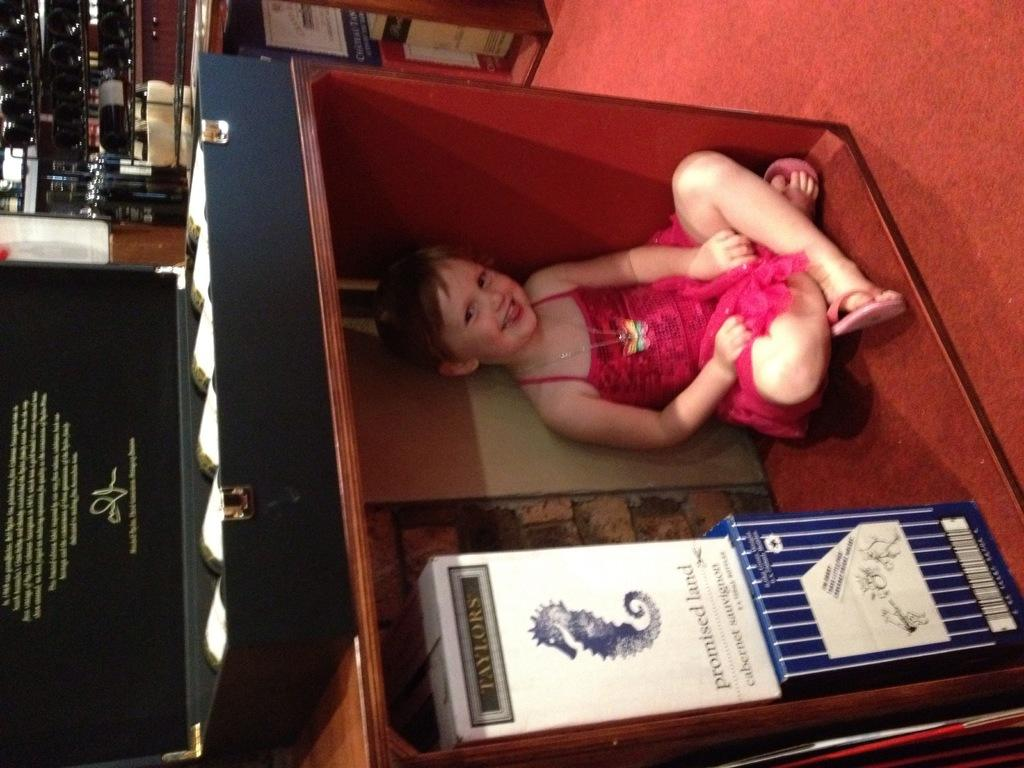What is the main subject of the picture? The main subject of the picture is a kid. What is the kid doing in the image? The kid is sitting and smiling. What can be seen at the bottom of the image? There are boxes at the bottom of the image. What is located on the left side of the image? There is a suitcase on the left side of the image. What is visible in the background of the image? There are objects present in the background of the image. What type of circle can be seen on the tray in the image? There is no tray or circle present in the image. What is the kid's level of fear in the image? The image does not provide any information about the kid's level of fear. 